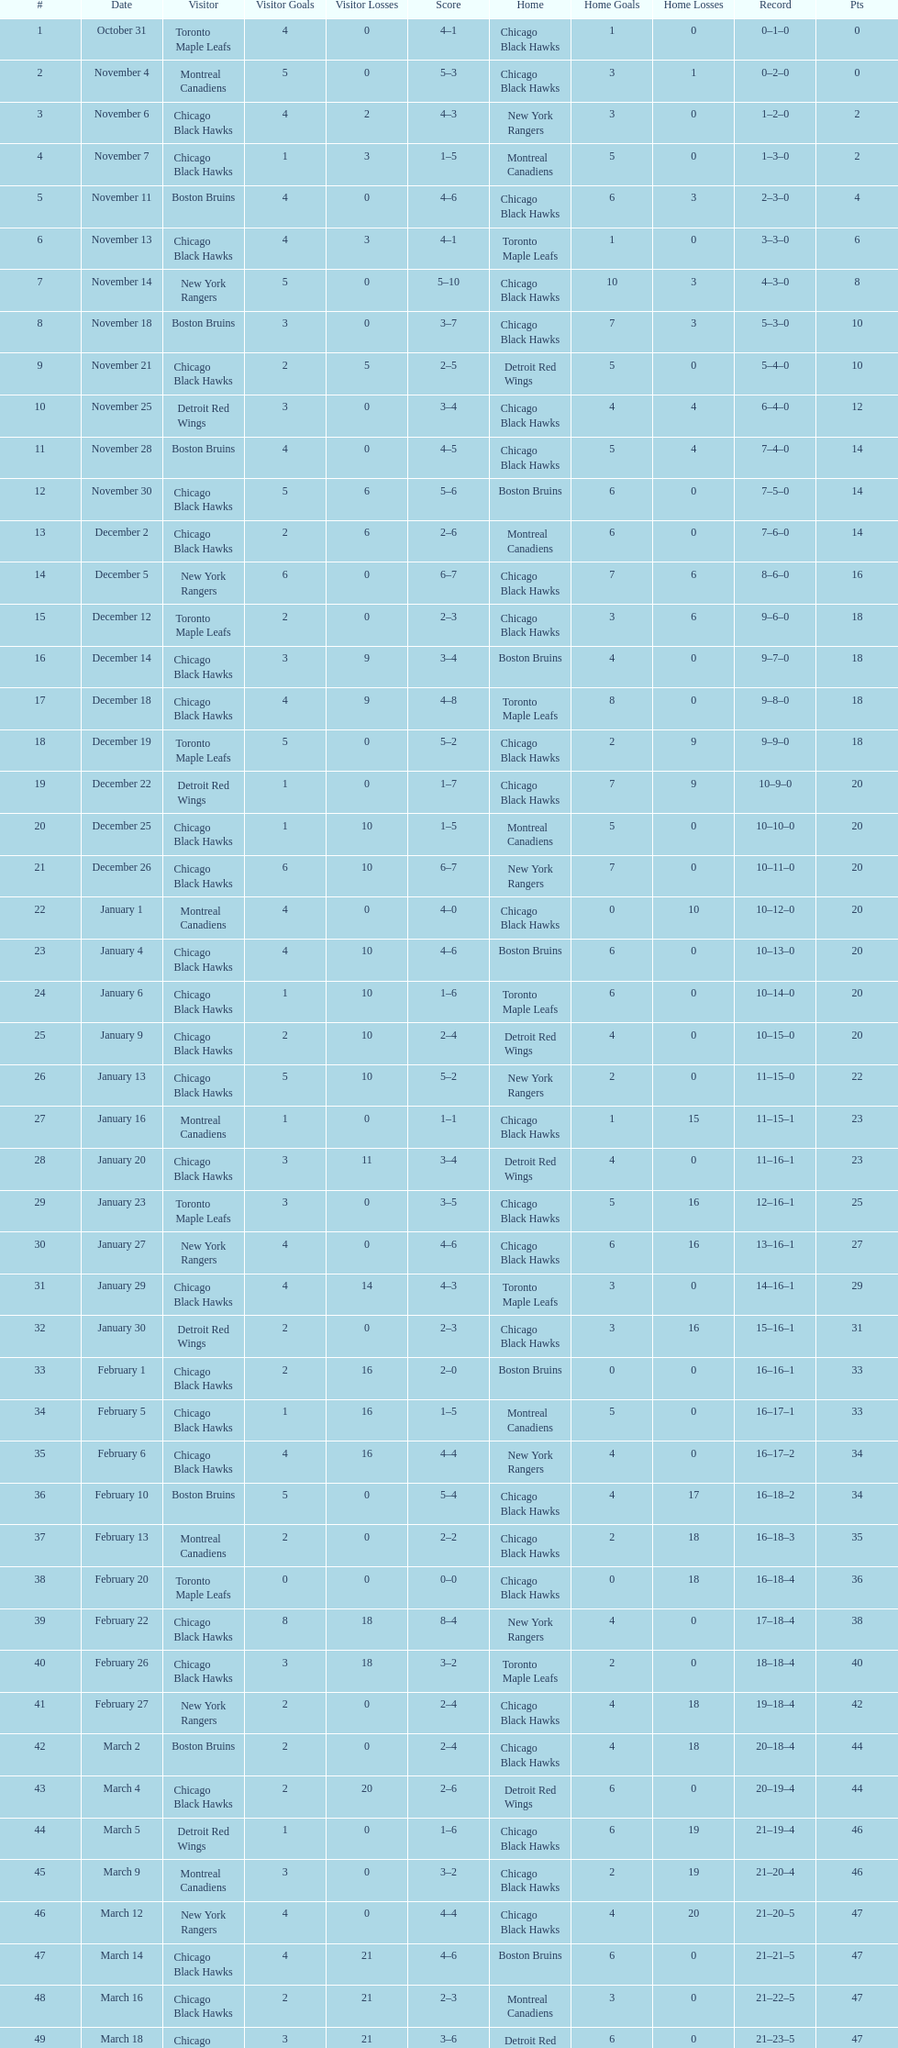Give me the full table as a dictionary. {'header': ['#', 'Date', 'Visitor', 'Visitor Goals', 'Visitor Losses', 'Score', 'Home', 'Home Goals', 'Home Losses', 'Record', 'Pts'], 'rows': [['1', 'October 31', 'Toronto Maple Leafs', '4', '0', '4–1', 'Chicago Black Hawks', '1', '0', '0–1–0', '0'], ['2', 'November 4', 'Montreal Canadiens', '5', '0', '5–3', 'Chicago Black Hawks', '3', '1', '0–2–0', '0'], ['3', 'November 6', 'Chicago Black Hawks', '4', '2', '4–3', 'New York Rangers', '3', '0', '1–2–0', '2'], ['4', 'November 7', 'Chicago Black Hawks', '1', '3', '1–5', 'Montreal Canadiens', '5', '0', '1–3–0', '2'], ['5', 'November 11', 'Boston Bruins', '4', '0', '4–6', 'Chicago Black Hawks', '6', '3', '2–3–0', '4'], ['6', 'November 13', 'Chicago Black Hawks', '4', '3', '4–1', 'Toronto Maple Leafs', '1', '0', '3–3–0', '6'], ['7', 'November 14', 'New York Rangers', '5', '0', '5–10', 'Chicago Black Hawks', '10', '3', '4–3–0', '8'], ['8', 'November 18', 'Boston Bruins', '3', '0', '3–7', 'Chicago Black Hawks', '7', '3', '5–3–0', '10'], ['9', 'November 21', 'Chicago Black Hawks', '2', '5', '2–5', 'Detroit Red Wings', '5', '0', '5–4–0', '10'], ['10', 'November 25', 'Detroit Red Wings', '3', '0', '3–4', 'Chicago Black Hawks', '4', '4', '6–4–0', '12'], ['11', 'November 28', 'Boston Bruins', '4', '0', '4–5', 'Chicago Black Hawks', '5', '4', '7–4–0', '14'], ['12', 'November 30', 'Chicago Black Hawks', '5', '6', '5–6', 'Boston Bruins', '6', '0', '7–5–0', '14'], ['13', 'December 2', 'Chicago Black Hawks', '2', '6', '2–6', 'Montreal Canadiens', '6', '0', '7–6–0', '14'], ['14', 'December 5', 'New York Rangers', '6', '0', '6–7', 'Chicago Black Hawks', '7', '6', '8–6–0', '16'], ['15', 'December 12', 'Toronto Maple Leafs', '2', '0', '2–3', 'Chicago Black Hawks', '3', '6', '9–6–0', '18'], ['16', 'December 14', 'Chicago Black Hawks', '3', '9', '3–4', 'Boston Bruins', '4', '0', '9–7–0', '18'], ['17', 'December 18', 'Chicago Black Hawks', '4', '9', '4–8', 'Toronto Maple Leafs', '8', '0', '9–8–0', '18'], ['18', 'December 19', 'Toronto Maple Leafs', '5', '0', '5–2', 'Chicago Black Hawks', '2', '9', '9–9–0', '18'], ['19', 'December 22', 'Detroit Red Wings', '1', '0', '1–7', 'Chicago Black Hawks', '7', '9', '10–9–0', '20'], ['20', 'December 25', 'Chicago Black Hawks', '1', '10', '1–5', 'Montreal Canadiens', '5', '0', '10–10–0', '20'], ['21', 'December 26', 'Chicago Black Hawks', '6', '10', '6–7', 'New York Rangers', '7', '0', '10–11–0', '20'], ['22', 'January 1', 'Montreal Canadiens', '4', '0', '4–0', 'Chicago Black Hawks', '0', '10', '10–12–0', '20'], ['23', 'January 4', 'Chicago Black Hawks', '4', '10', '4–6', 'Boston Bruins', '6', '0', '10–13–0', '20'], ['24', 'January 6', 'Chicago Black Hawks', '1', '10', '1–6', 'Toronto Maple Leafs', '6', '0', '10–14–0', '20'], ['25', 'January 9', 'Chicago Black Hawks', '2', '10', '2–4', 'Detroit Red Wings', '4', '0', '10–15–0', '20'], ['26', 'January 13', 'Chicago Black Hawks', '5', '10', '5–2', 'New York Rangers', '2', '0', '11–15–0', '22'], ['27', 'January 16', 'Montreal Canadiens', '1', '0', '1–1', 'Chicago Black Hawks', '1', '15', '11–15–1', '23'], ['28', 'January 20', 'Chicago Black Hawks', '3', '11', '3–4', 'Detroit Red Wings', '4', '0', '11–16–1', '23'], ['29', 'January 23', 'Toronto Maple Leafs', '3', '0', '3–5', 'Chicago Black Hawks', '5', '16', '12–16–1', '25'], ['30', 'January 27', 'New York Rangers', '4', '0', '4–6', 'Chicago Black Hawks', '6', '16', '13–16–1', '27'], ['31', 'January 29', 'Chicago Black Hawks', '4', '14', '4–3', 'Toronto Maple Leafs', '3', '0', '14–16–1', '29'], ['32', 'January 30', 'Detroit Red Wings', '2', '0', '2–3', 'Chicago Black Hawks', '3', '16', '15–16–1', '31'], ['33', 'February 1', 'Chicago Black Hawks', '2', '16', '2–0', 'Boston Bruins', '0', '0', '16–16–1', '33'], ['34', 'February 5', 'Chicago Black Hawks', '1', '16', '1–5', 'Montreal Canadiens', '5', '0', '16–17–1', '33'], ['35', 'February 6', 'Chicago Black Hawks', '4', '16', '4–4', 'New York Rangers', '4', '0', '16–17–2', '34'], ['36', 'February 10', 'Boston Bruins', '5', '0', '5–4', 'Chicago Black Hawks', '4', '17', '16–18–2', '34'], ['37', 'February 13', 'Montreal Canadiens', '2', '0', '2–2', 'Chicago Black Hawks', '2', '18', '16–18–3', '35'], ['38', 'February 20', 'Toronto Maple Leafs', '0', '0', '0–0', 'Chicago Black Hawks', '0', '18', '16–18–4', '36'], ['39', 'February 22', 'Chicago Black Hawks', '8', '18', '8–4', 'New York Rangers', '4', '0', '17–18–4', '38'], ['40', 'February 26', 'Chicago Black Hawks', '3', '18', '3–2', 'Toronto Maple Leafs', '2', '0', '18–18–4', '40'], ['41', 'February 27', 'New York Rangers', '2', '0', '2–4', 'Chicago Black Hawks', '4', '18', '19–18–4', '42'], ['42', 'March 2', 'Boston Bruins', '2', '0', '2–4', 'Chicago Black Hawks', '4', '18', '20–18–4', '44'], ['43', 'March 4', 'Chicago Black Hawks', '2', '20', '2–6', 'Detroit Red Wings', '6', '0', '20–19–4', '44'], ['44', 'March 5', 'Detroit Red Wings', '1', '0', '1–6', 'Chicago Black Hawks', '6', '19', '21–19–4', '46'], ['45', 'March 9', 'Montreal Canadiens', '3', '0', '3–2', 'Chicago Black Hawks', '2', '19', '21–20–4', '46'], ['46', 'March 12', 'New York Rangers', '4', '0', '4–4', 'Chicago Black Hawks', '4', '20', '21–20–5', '47'], ['47', 'March 14', 'Chicago Black Hawks', '4', '21', '4–6', 'Boston Bruins', '6', '0', '21–21–5', '47'], ['48', 'March 16', 'Chicago Black Hawks', '2', '21', '2–3', 'Montreal Canadiens', '3', '0', '21–22–5', '47'], ['49', 'March 18', 'Chicago Black Hawks', '3', '21', '3–6', 'Detroit Red Wings', '6', '0', '21–23–5', '47'], ['50', 'March 19', 'Detroit Red Wings', '0', '0', '0–2', 'Chicago Black Hawks', '2', '23', '22–23–5', '49']]} Which team was the first one the black hawks suffered a loss to? Toronto Maple Leafs. 